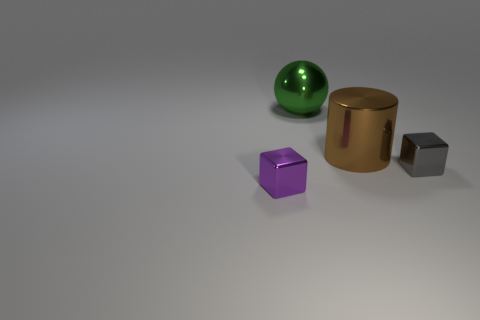How many spheres are on the left side of the big metallic sphere?
Your answer should be very brief. 0. How many other objects are the same size as the gray object?
Make the answer very short. 1. Is the object that is behind the big cylinder made of the same material as the block that is right of the purple metal cube?
Give a very brief answer. Yes. There is a metallic sphere that is the same size as the brown metallic object; what is its color?
Your answer should be compact. Green. Are there any other things that have the same color as the large metal ball?
Ensure brevity in your answer.  No. What is the size of the metal block to the left of the big metallic object to the right of the big object that is behind the big shiny cylinder?
Your response must be concise. Small. There is a metallic object that is left of the big brown thing and in front of the big metallic cylinder; what color is it?
Your response must be concise. Purple. There is a gray metal cube to the right of the big green thing; how big is it?
Ensure brevity in your answer.  Small. How many big brown objects have the same material as the purple cube?
Provide a short and direct response. 1. There is a tiny object right of the purple shiny cube; is it the same shape as the big brown metal thing?
Offer a very short reply. No. 